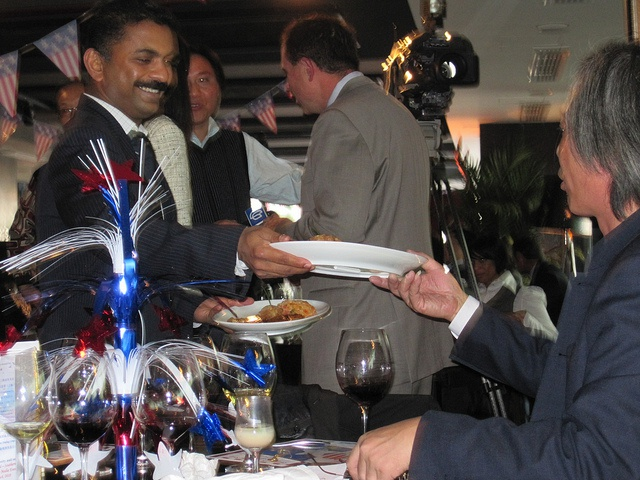Describe the objects in this image and their specific colors. I can see people in black, gray, and brown tones, people in black, gray, brown, and lightgray tones, people in black, brown, and maroon tones, people in black, darkgray, maroon, and gray tones, and wine glass in black, gray, darkgray, and lightgray tones in this image. 